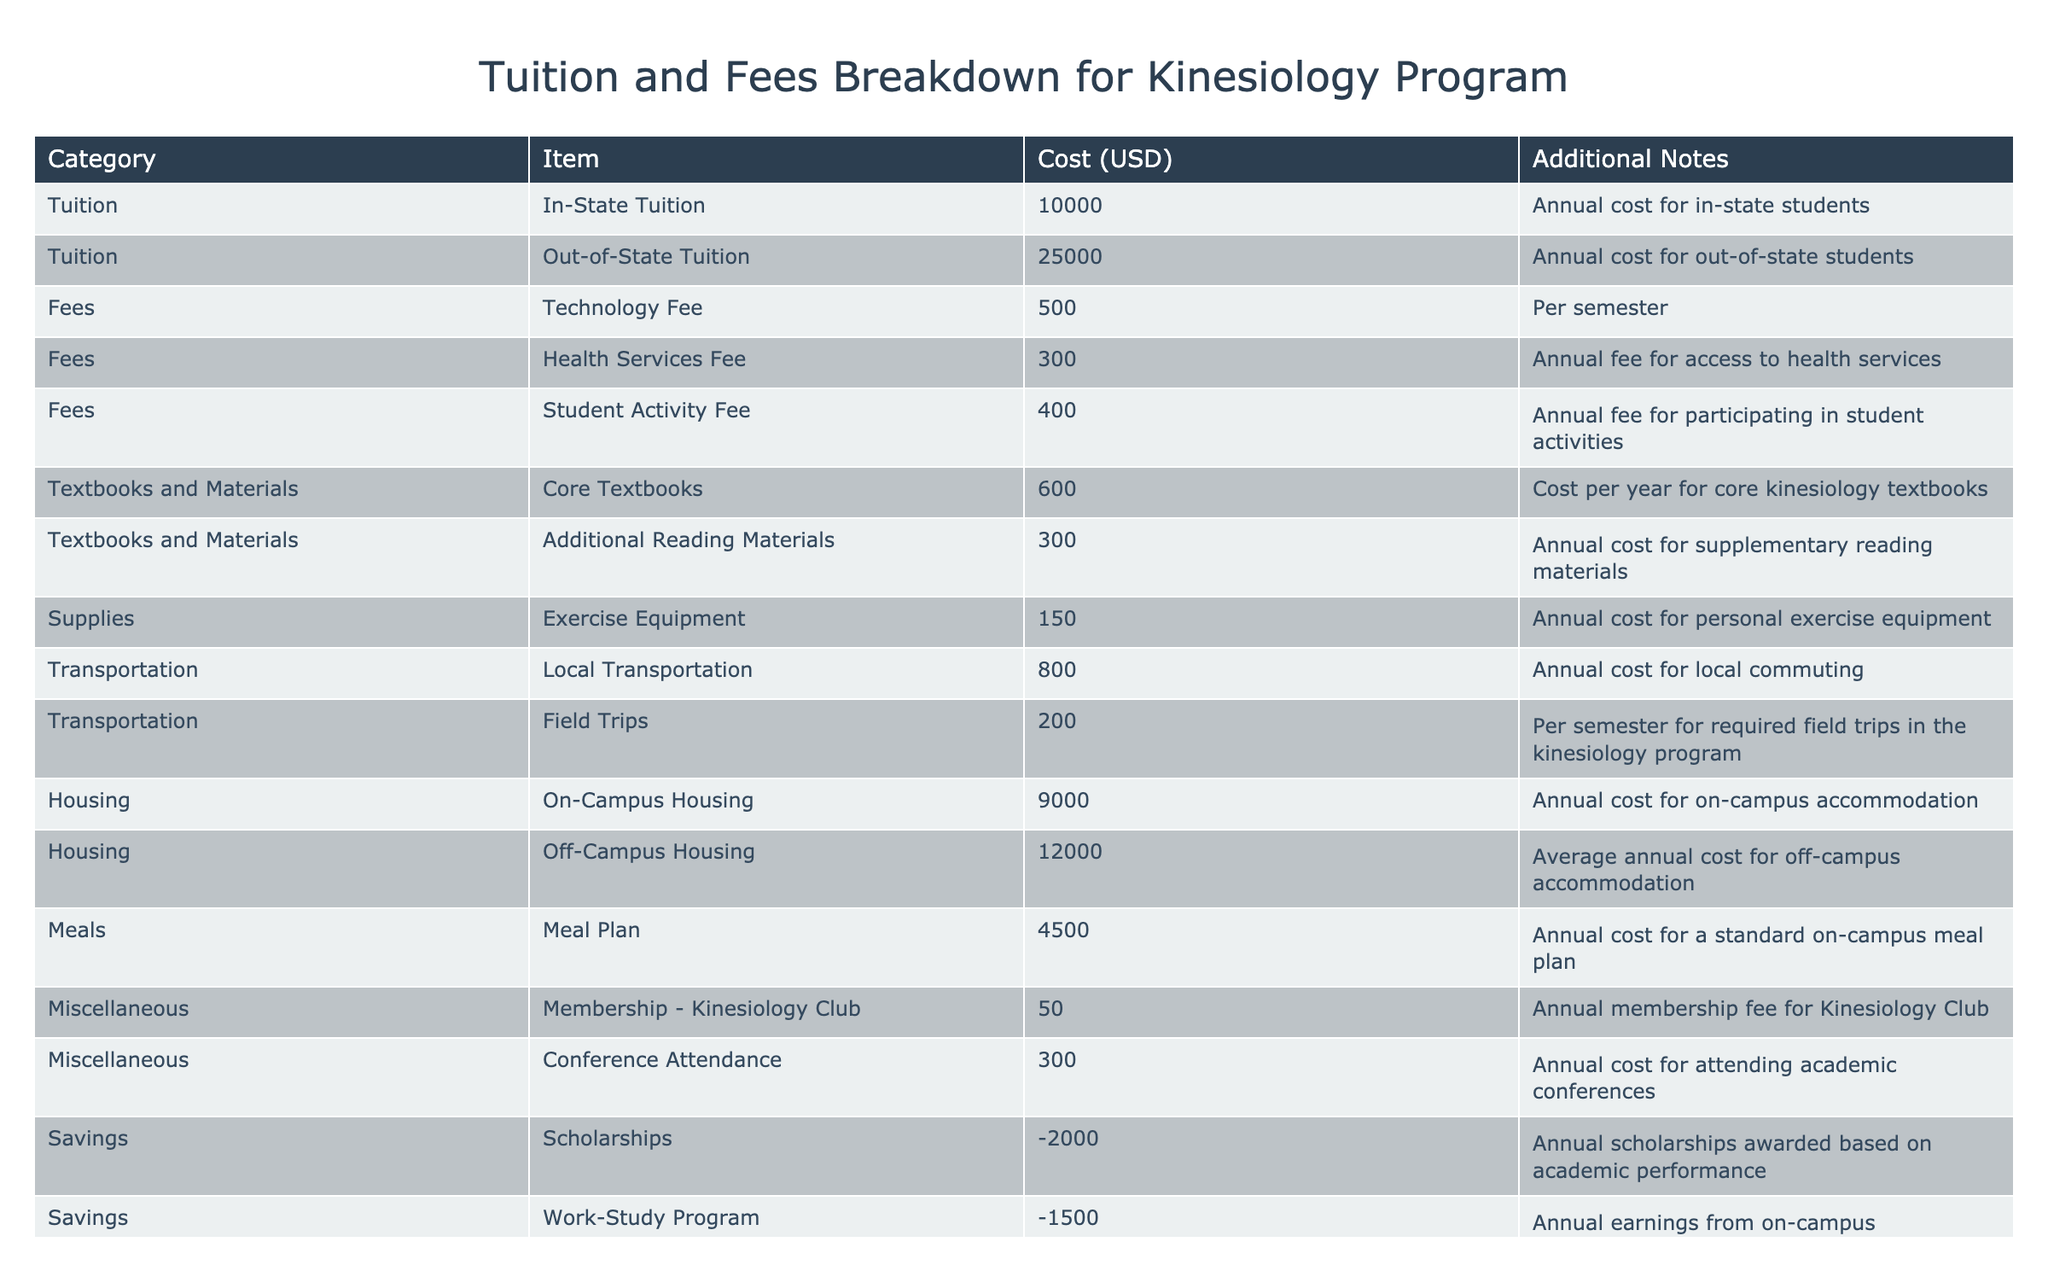What is the total cost of in-state tuition for a year? The in-state tuition cost listed in the table is $10,000. So, for one year, the total cost is simply that stated value.
Answer: 10000 What are the annual fees for health services and student activities combined? The cost for the Health Services Fee is $300, and the Student Activity Fee is $400. To find the total, add these two amounts: 300 + 400 = 700.
Answer: 700 Is the additional reading materials cost higher than the core textbooks cost? The cost for additional reading materials is $300, while the cost for core textbooks is $600. Since 300 is less than 600, the statement is false.
Answer: No What is the total cost of living on-campus, including the meal plan? The total cost is calculated by adding the On-Campus Housing cost ($9,000) and the Meal Plan cost ($4,500). Therefore, 9000 + 4500 = 13500.
Answer: 13500 What is the difference between the annual cost of housing on-campus and off-campus? The On-Campus Housing cost is $9,000, and the Off-Campus Housing cost is $12,000. To find the difference, subtract the on-campus cost from the off-campus cost: 12000 - 9000 = 3000.
Answer: 3000 How much total will a student save from scholarships and a work-study program? The student will save $2,000 from scholarships and $1,500 from the work-study program. Thus, total savings is: -2000 + (-1500) = -3500, indicating overall savings of $3,500.
Answer: 3500 What is the total amount spent on textbooks and materials for a year? The total amount is the sum of core textbooks ($600) and additional reading materials ($300). Therefore, 600 + 300 = 900 for the total annual cost.
Answer: 900 Are field trip costs higher than local transportation costs? The Field Trips cost per semester is listed as $200, while Local Transportation is an annual cost of $800. Since $200 is less than $800, the statement is false.
Answer: No 